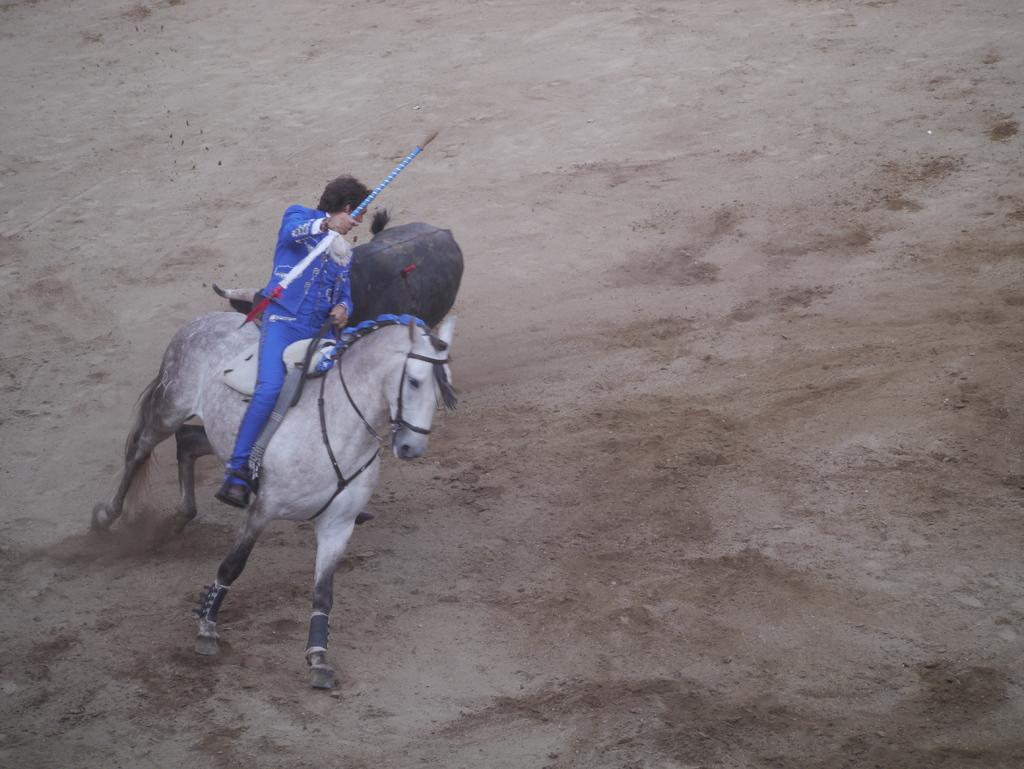What is the main subject of the image? There is a man in the image. What is the man wearing? The man is wearing clothes and shoes. What is the man holding in his hand? The man is holding a stick in his hand. What is the man doing in the image? The man is riding a horse. What type of terrain can be seen in the image? There is sand visible in the image. What other animal can be seen in the image? There is another animal, which is black in color, in the image. What type of cave can be seen in the image? There is no cave present in the image. What is the floor made of in the image? The image does not show a floor, as it features a man riding a horse on sandy terrain. 